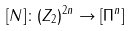<formula> <loc_0><loc_0><loc_500><loc_500>[ N ] \colon ( Z _ { 2 } ) ^ { 2 n } \rightarrow [ \Pi ^ { n } ]</formula> 